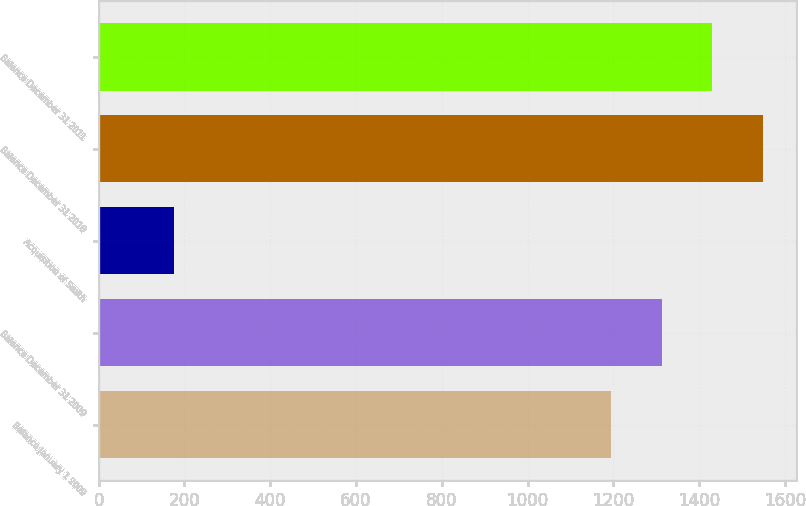<chart> <loc_0><loc_0><loc_500><loc_500><bar_chart><fcel>Balance January 1 2009<fcel>Balance December 31 2009<fcel>Acquisition of Smith<fcel>Balance December 31 2010<fcel>Balance December 31 2011<nl><fcel>1194<fcel>1312.5<fcel>176<fcel>1549.5<fcel>1431<nl></chart> 